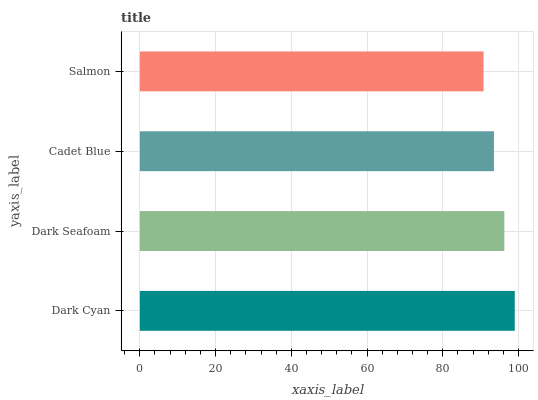Is Salmon the minimum?
Answer yes or no. Yes. Is Dark Cyan the maximum?
Answer yes or no. Yes. Is Dark Seafoam the minimum?
Answer yes or no. No. Is Dark Seafoam the maximum?
Answer yes or no. No. Is Dark Cyan greater than Dark Seafoam?
Answer yes or no. Yes. Is Dark Seafoam less than Dark Cyan?
Answer yes or no. Yes. Is Dark Seafoam greater than Dark Cyan?
Answer yes or no. No. Is Dark Cyan less than Dark Seafoam?
Answer yes or no. No. Is Dark Seafoam the high median?
Answer yes or no. Yes. Is Cadet Blue the low median?
Answer yes or no. Yes. Is Cadet Blue the high median?
Answer yes or no. No. Is Dark Cyan the low median?
Answer yes or no. No. 